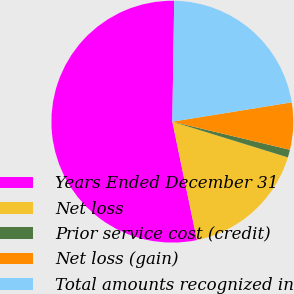Convert chart to OTSL. <chart><loc_0><loc_0><loc_500><loc_500><pie_chart><fcel>Years Ended December 31<fcel>Net loss<fcel>Prior service cost (credit)<fcel>Net loss (gain)<fcel>Total amounts recognized in<nl><fcel>53.51%<fcel>16.96%<fcel>1.04%<fcel>6.29%<fcel>22.2%<nl></chart> 